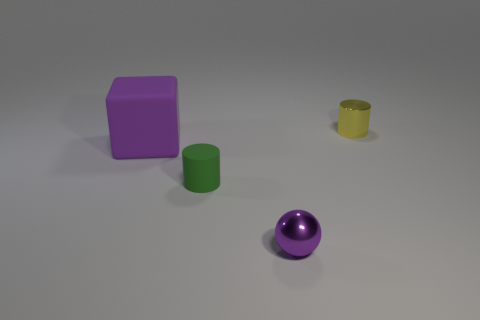Add 2 tiny yellow metal things. How many objects exist? 6 Subtract all cubes. How many objects are left? 3 Add 1 metal cylinders. How many metal cylinders exist? 2 Subtract 0 brown blocks. How many objects are left? 4 Subtract all large yellow matte cylinders. Subtract all purple spheres. How many objects are left? 3 Add 4 small green things. How many small green things are left? 5 